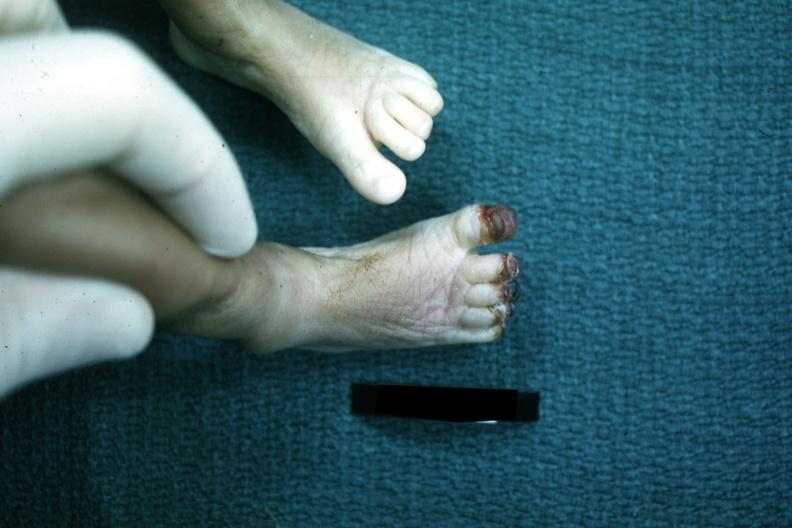does this image show foot of infant with gangrenous tips of all toes case of sepsis with dic?
Answer the question using a single word or phrase. Yes 